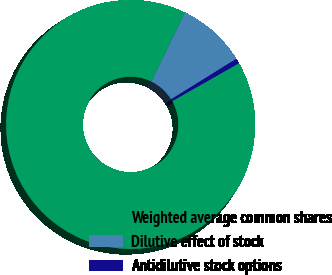<chart> <loc_0><loc_0><loc_500><loc_500><pie_chart><fcel>Weighted average common shares<fcel>Dilutive effect of stock<fcel>Antidilutive stock options<nl><fcel>90.41%<fcel>8.95%<fcel>0.64%<nl></chart> 